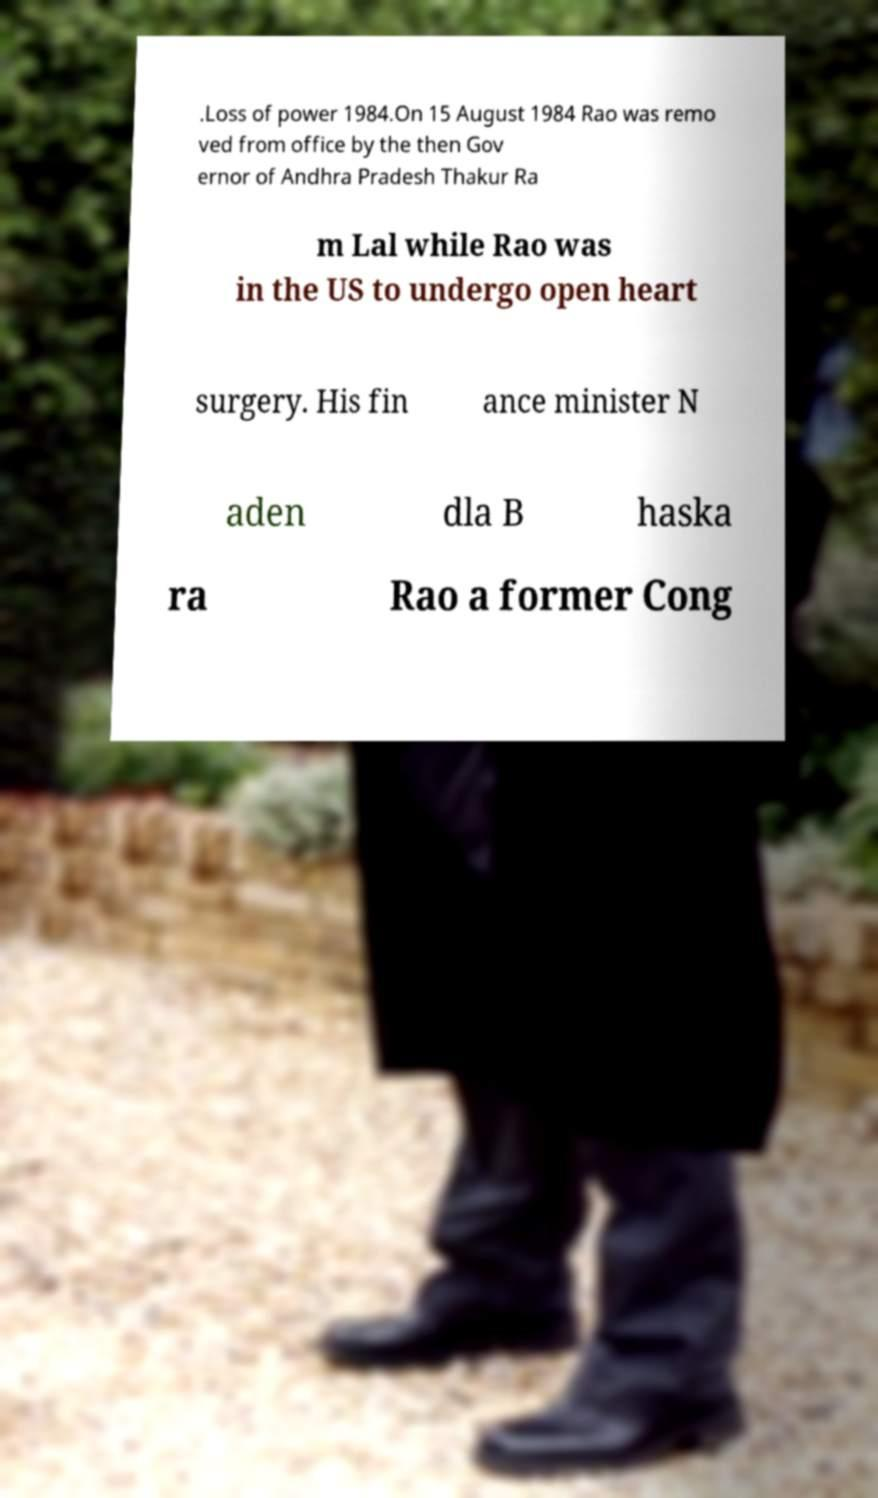Could you extract and type out the text from this image? .Loss of power 1984.On 15 August 1984 Rao was remo ved from office by the then Gov ernor of Andhra Pradesh Thakur Ra m Lal while Rao was in the US to undergo open heart surgery. His fin ance minister N aden dla B haska ra Rao a former Cong 